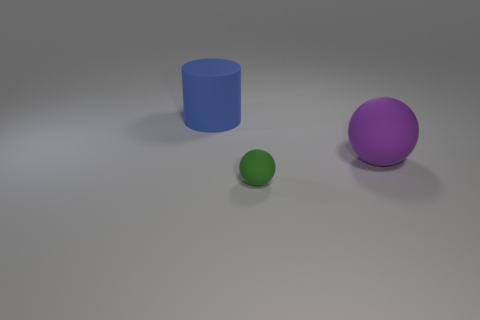Add 2 cylinders. How many objects exist? 5 Subtract all cylinders. How many objects are left? 2 Add 2 small rubber spheres. How many small rubber spheres are left? 3 Add 2 tiny red rubber cylinders. How many tiny red rubber cylinders exist? 2 Subtract 0 gray balls. How many objects are left? 3 Subtract all purple spheres. Subtract all small balls. How many objects are left? 1 